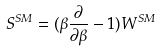<formula> <loc_0><loc_0><loc_500><loc_500>S ^ { S M } = ( \beta \frac { \partial } { \partial \beta } - 1 ) W ^ { S M }</formula> 